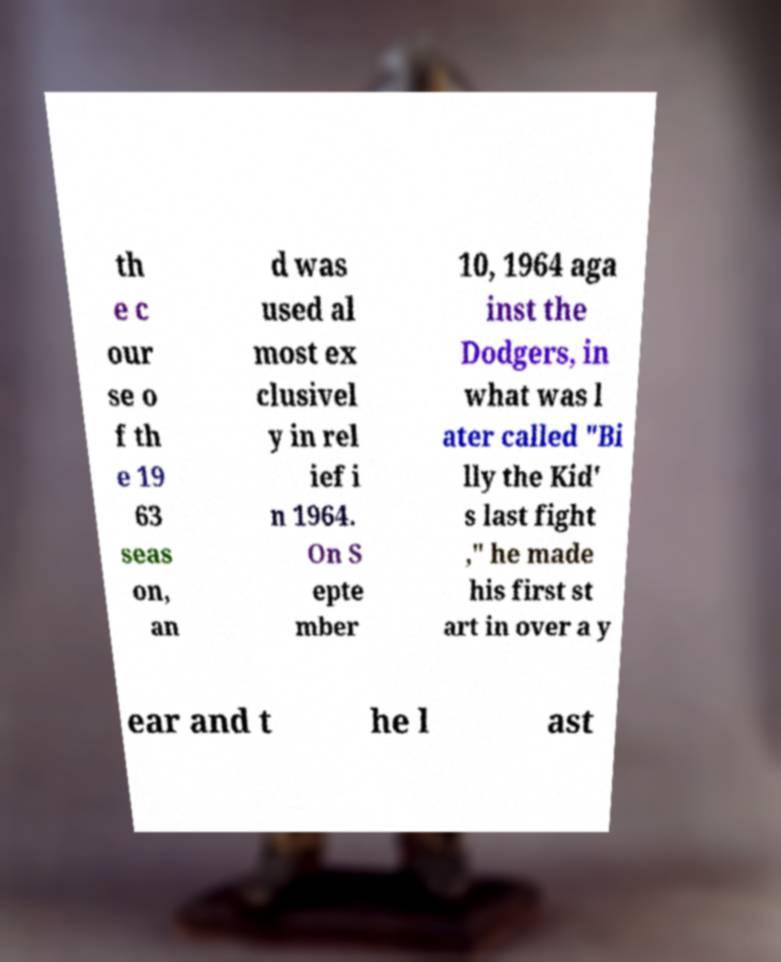For documentation purposes, I need the text within this image transcribed. Could you provide that? th e c our se o f th e 19 63 seas on, an d was used al most ex clusivel y in rel ief i n 1964. On S epte mber 10, 1964 aga inst the Dodgers, in what was l ater called "Bi lly the Kid' s last fight ," he made his first st art in over a y ear and t he l ast 